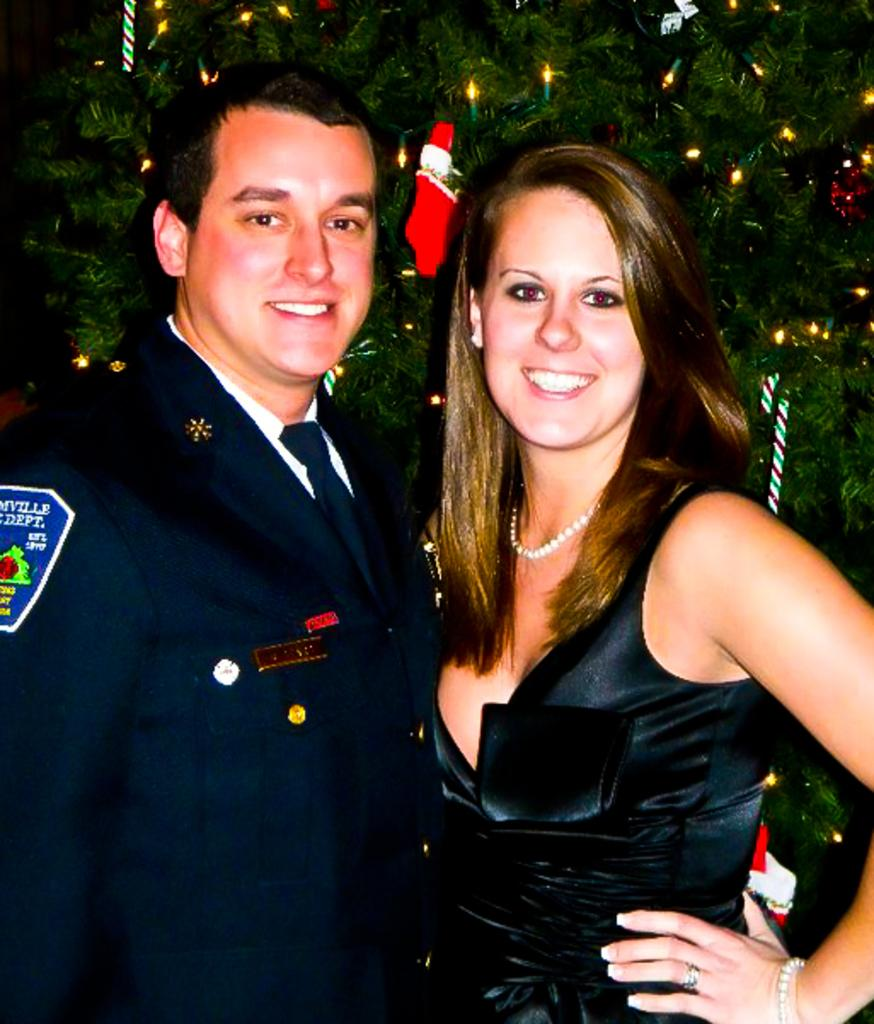Who can be seen in the foreground of the image? There is a man and a woman in the foreground of the image. What are the man and the woman doing in the image? The man and the woman are standing and smiling. What can be seen in the background of the image? There is a tree in the background of the image. How is the tree in the image decorated? The tree is decorated, but the specific decorations are not mentioned in the facts. What type of bait is being used to catch fish in the image? There is no mention of fishing or bait in the image, so it cannot be determined from the facts. What is the cause of the fog in the image? There is no fog present in the image, so it cannot be determined from the facts. 